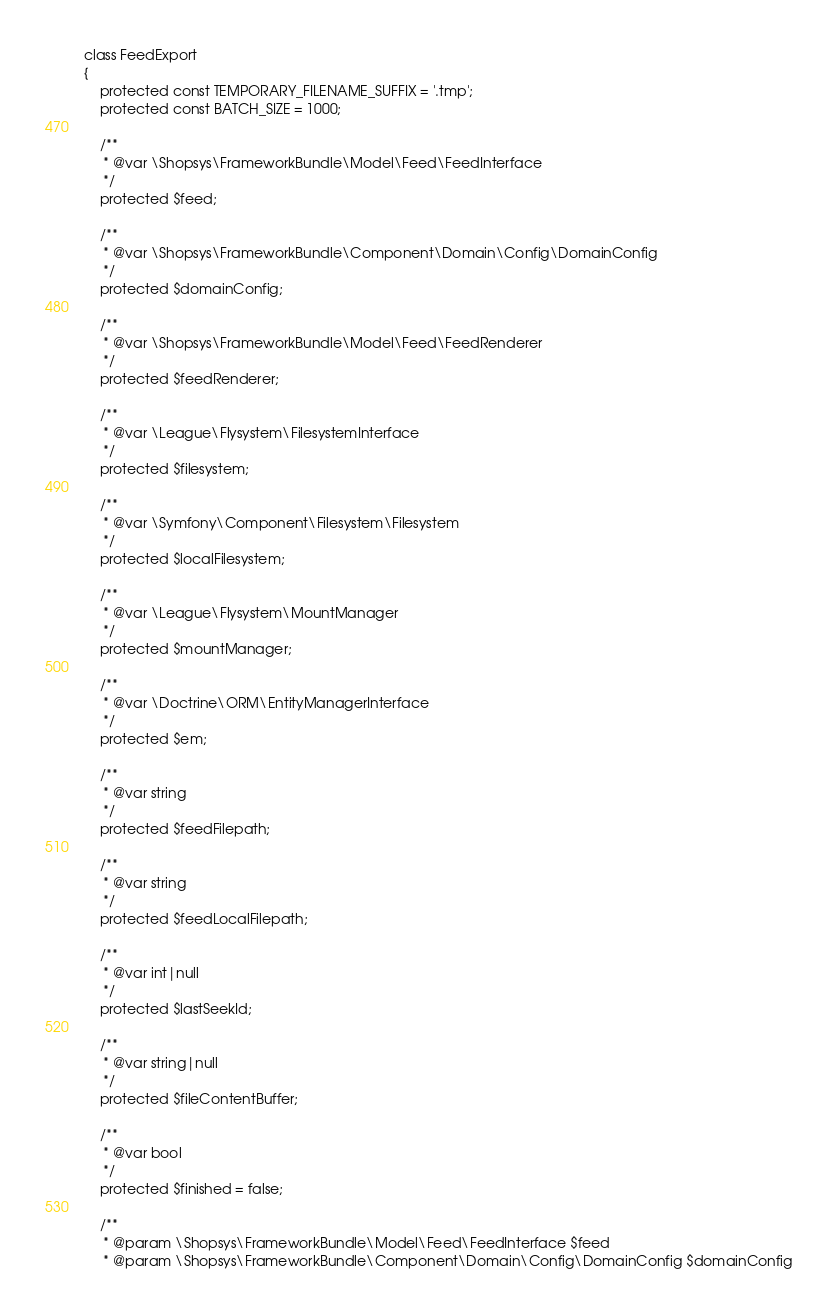Convert code to text. <code><loc_0><loc_0><loc_500><loc_500><_PHP_>class FeedExport
{
    protected const TEMPORARY_FILENAME_SUFFIX = '.tmp';
    protected const BATCH_SIZE = 1000;

    /**
     * @var \Shopsys\FrameworkBundle\Model\Feed\FeedInterface
     */
    protected $feed;

    /**
     * @var \Shopsys\FrameworkBundle\Component\Domain\Config\DomainConfig
     */
    protected $domainConfig;

    /**
     * @var \Shopsys\FrameworkBundle\Model\Feed\FeedRenderer
     */
    protected $feedRenderer;

    /**
     * @var \League\Flysystem\FilesystemInterface
     */
    protected $filesystem;

    /**
     * @var \Symfony\Component\Filesystem\Filesystem
     */
    protected $localFilesystem;

    /**
     * @var \League\Flysystem\MountManager
     */
    protected $mountManager;

    /**
     * @var \Doctrine\ORM\EntityManagerInterface
     */
    protected $em;

    /**
     * @var string
     */
    protected $feedFilepath;

    /**
     * @var string
     */
    protected $feedLocalFilepath;

    /**
     * @var int|null
     */
    protected $lastSeekId;

    /**
     * @var string|null
     */
    protected $fileContentBuffer;

    /**
     * @var bool
     */
    protected $finished = false;

    /**
     * @param \Shopsys\FrameworkBundle\Model\Feed\FeedInterface $feed
     * @param \Shopsys\FrameworkBundle\Component\Domain\Config\DomainConfig $domainConfig</code> 